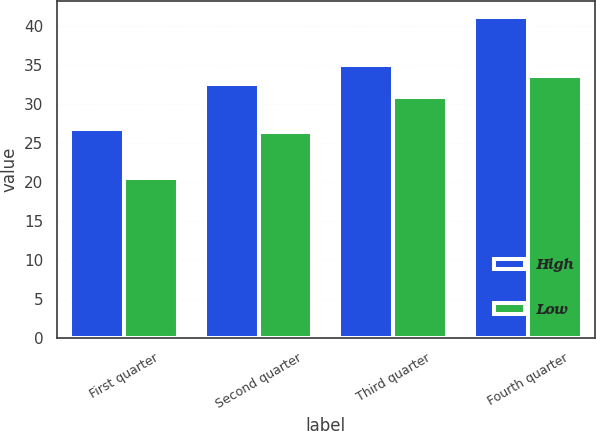Convert chart. <chart><loc_0><loc_0><loc_500><loc_500><stacked_bar_chart><ecel><fcel>First quarter<fcel>Second quarter<fcel>Third quarter<fcel>Fourth quarter<nl><fcel>High<fcel>26.82<fcel>32.64<fcel>35.03<fcel>41.17<nl><fcel>Low<fcel>20.5<fcel>26.4<fcel>30.9<fcel>33.66<nl></chart> 